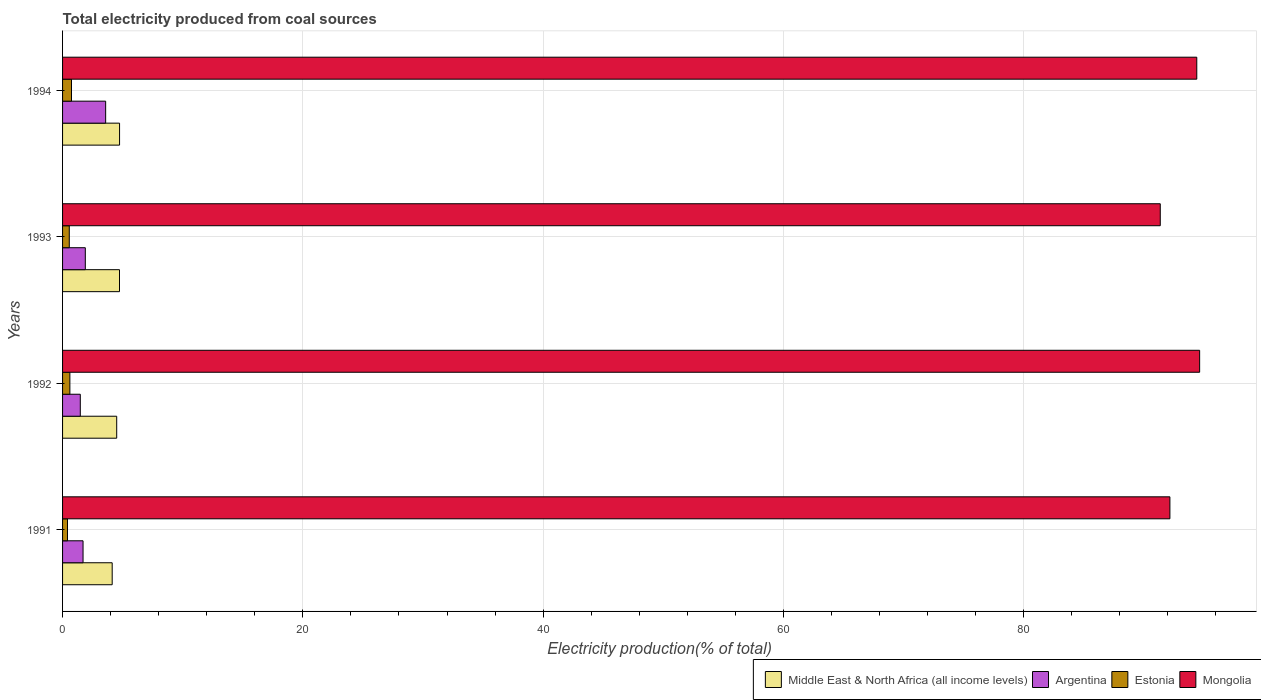Are the number of bars per tick equal to the number of legend labels?
Offer a terse response. Yes. How many bars are there on the 4th tick from the top?
Offer a very short reply. 4. How many bars are there on the 4th tick from the bottom?
Keep it short and to the point. 4. What is the label of the 2nd group of bars from the top?
Ensure brevity in your answer.  1993. What is the total electricity produced in Argentina in 1991?
Offer a very short reply. 1.7. Across all years, what is the maximum total electricity produced in Argentina?
Ensure brevity in your answer.  3.59. Across all years, what is the minimum total electricity produced in Mongolia?
Give a very brief answer. 91.36. In which year was the total electricity produced in Middle East & North Africa (all income levels) maximum?
Offer a terse response. 1994. In which year was the total electricity produced in Argentina minimum?
Give a very brief answer. 1992. What is the total total electricity produced in Middle East & North Africa (all income levels) in the graph?
Give a very brief answer. 18.12. What is the difference between the total electricity produced in Argentina in 1991 and that in 1994?
Make the answer very short. -1.88. What is the difference between the total electricity produced in Middle East & North Africa (all income levels) in 1992 and the total electricity produced in Estonia in 1991?
Make the answer very short. 4.1. What is the average total electricity produced in Argentina per year?
Your answer should be compact. 2.17. In the year 1991, what is the difference between the total electricity produced in Middle East & North Africa (all income levels) and total electricity produced in Argentina?
Make the answer very short. 2.43. What is the ratio of the total electricity produced in Middle East & North Africa (all income levels) in 1993 to that in 1994?
Offer a very short reply. 1. Is the total electricity produced in Argentina in 1991 less than that in 1993?
Your answer should be very brief. Yes. What is the difference between the highest and the second highest total electricity produced in Mongolia?
Offer a terse response. 0.24. What is the difference between the highest and the lowest total electricity produced in Middle East & North Africa (all income levels)?
Provide a short and direct response. 0.61. In how many years, is the total electricity produced in Estonia greater than the average total electricity produced in Estonia taken over all years?
Keep it short and to the point. 2. Is the sum of the total electricity produced in Estonia in 1992 and 1993 greater than the maximum total electricity produced in Argentina across all years?
Keep it short and to the point. No. What does the 2nd bar from the top in 1993 represents?
Keep it short and to the point. Estonia. Is it the case that in every year, the sum of the total electricity produced in Middle East & North Africa (all income levels) and total electricity produced in Argentina is greater than the total electricity produced in Mongolia?
Give a very brief answer. No. How many years are there in the graph?
Keep it short and to the point. 4. Are the values on the major ticks of X-axis written in scientific E-notation?
Keep it short and to the point. No. Does the graph contain any zero values?
Provide a short and direct response. No. How many legend labels are there?
Provide a short and direct response. 4. What is the title of the graph?
Give a very brief answer. Total electricity produced from coal sources. Does "St. Lucia" appear as one of the legend labels in the graph?
Provide a succinct answer. No. What is the label or title of the Y-axis?
Offer a very short reply. Years. What is the Electricity production(% of total) of Middle East & North Africa (all income levels) in 1991?
Keep it short and to the point. 4.13. What is the Electricity production(% of total) in Argentina in 1991?
Your answer should be compact. 1.7. What is the Electricity production(% of total) of Estonia in 1991?
Ensure brevity in your answer.  0.41. What is the Electricity production(% of total) in Mongolia in 1991?
Your answer should be very brief. 92.16. What is the Electricity production(% of total) in Middle East & North Africa (all income levels) in 1992?
Offer a very short reply. 4.51. What is the Electricity production(% of total) in Argentina in 1992?
Your response must be concise. 1.48. What is the Electricity production(% of total) of Estonia in 1992?
Give a very brief answer. 0.61. What is the Electricity production(% of total) of Mongolia in 1992?
Provide a succinct answer. 94.64. What is the Electricity production(% of total) of Middle East & North Africa (all income levels) in 1993?
Offer a terse response. 4.74. What is the Electricity production(% of total) of Argentina in 1993?
Give a very brief answer. 1.89. What is the Electricity production(% of total) in Estonia in 1993?
Offer a terse response. 0.56. What is the Electricity production(% of total) of Mongolia in 1993?
Your answer should be compact. 91.36. What is the Electricity production(% of total) of Middle East & North Africa (all income levels) in 1994?
Provide a succinct answer. 4.74. What is the Electricity production(% of total) in Argentina in 1994?
Give a very brief answer. 3.59. What is the Electricity production(% of total) in Estonia in 1994?
Offer a terse response. 0.74. What is the Electricity production(% of total) of Mongolia in 1994?
Provide a short and direct response. 94.4. Across all years, what is the maximum Electricity production(% of total) in Middle East & North Africa (all income levels)?
Your answer should be very brief. 4.74. Across all years, what is the maximum Electricity production(% of total) in Argentina?
Provide a short and direct response. 3.59. Across all years, what is the maximum Electricity production(% of total) of Estonia?
Ensure brevity in your answer.  0.74. Across all years, what is the maximum Electricity production(% of total) of Mongolia?
Provide a short and direct response. 94.64. Across all years, what is the minimum Electricity production(% of total) of Middle East & North Africa (all income levels)?
Offer a very short reply. 4.13. Across all years, what is the minimum Electricity production(% of total) in Argentina?
Provide a succinct answer. 1.48. Across all years, what is the minimum Electricity production(% of total) in Estonia?
Your response must be concise. 0.41. Across all years, what is the minimum Electricity production(% of total) of Mongolia?
Ensure brevity in your answer.  91.36. What is the total Electricity production(% of total) of Middle East & North Africa (all income levels) in the graph?
Your answer should be compact. 18.12. What is the total Electricity production(% of total) in Argentina in the graph?
Give a very brief answer. 8.66. What is the total Electricity production(% of total) of Estonia in the graph?
Provide a short and direct response. 2.32. What is the total Electricity production(% of total) of Mongolia in the graph?
Offer a very short reply. 372.57. What is the difference between the Electricity production(% of total) in Middle East & North Africa (all income levels) in 1991 and that in 1992?
Ensure brevity in your answer.  -0.38. What is the difference between the Electricity production(% of total) of Argentina in 1991 and that in 1992?
Your answer should be compact. 0.23. What is the difference between the Electricity production(% of total) of Estonia in 1991 and that in 1992?
Your answer should be compact. -0.2. What is the difference between the Electricity production(% of total) of Mongolia in 1991 and that in 1992?
Your response must be concise. -2.48. What is the difference between the Electricity production(% of total) of Middle East & North Africa (all income levels) in 1991 and that in 1993?
Make the answer very short. -0.61. What is the difference between the Electricity production(% of total) of Argentina in 1991 and that in 1993?
Make the answer very short. -0.19. What is the difference between the Electricity production(% of total) in Estonia in 1991 and that in 1993?
Your answer should be compact. -0.15. What is the difference between the Electricity production(% of total) of Mongolia in 1991 and that in 1993?
Offer a very short reply. 0.8. What is the difference between the Electricity production(% of total) of Middle East & North Africa (all income levels) in 1991 and that in 1994?
Offer a terse response. -0.61. What is the difference between the Electricity production(% of total) of Argentina in 1991 and that in 1994?
Make the answer very short. -1.88. What is the difference between the Electricity production(% of total) of Estonia in 1991 and that in 1994?
Provide a succinct answer. -0.33. What is the difference between the Electricity production(% of total) in Mongolia in 1991 and that in 1994?
Offer a very short reply. -2.24. What is the difference between the Electricity production(% of total) in Middle East & North Africa (all income levels) in 1992 and that in 1993?
Offer a very short reply. -0.23. What is the difference between the Electricity production(% of total) in Argentina in 1992 and that in 1993?
Your response must be concise. -0.42. What is the difference between the Electricity production(% of total) in Estonia in 1992 and that in 1993?
Your answer should be very brief. 0.05. What is the difference between the Electricity production(% of total) in Mongolia in 1992 and that in 1993?
Your answer should be very brief. 3.28. What is the difference between the Electricity production(% of total) of Middle East & North Africa (all income levels) in 1992 and that in 1994?
Provide a succinct answer. -0.24. What is the difference between the Electricity production(% of total) in Argentina in 1992 and that in 1994?
Ensure brevity in your answer.  -2.11. What is the difference between the Electricity production(% of total) of Estonia in 1992 and that in 1994?
Offer a terse response. -0.13. What is the difference between the Electricity production(% of total) in Mongolia in 1992 and that in 1994?
Give a very brief answer. 0.24. What is the difference between the Electricity production(% of total) of Middle East & North Africa (all income levels) in 1993 and that in 1994?
Offer a terse response. -0.01. What is the difference between the Electricity production(% of total) of Argentina in 1993 and that in 1994?
Offer a very short reply. -1.69. What is the difference between the Electricity production(% of total) of Estonia in 1993 and that in 1994?
Provide a short and direct response. -0.18. What is the difference between the Electricity production(% of total) in Mongolia in 1993 and that in 1994?
Provide a short and direct response. -3.04. What is the difference between the Electricity production(% of total) in Middle East & North Africa (all income levels) in 1991 and the Electricity production(% of total) in Argentina in 1992?
Your answer should be compact. 2.65. What is the difference between the Electricity production(% of total) of Middle East & North Africa (all income levels) in 1991 and the Electricity production(% of total) of Estonia in 1992?
Make the answer very short. 3.52. What is the difference between the Electricity production(% of total) of Middle East & North Africa (all income levels) in 1991 and the Electricity production(% of total) of Mongolia in 1992?
Your response must be concise. -90.51. What is the difference between the Electricity production(% of total) in Argentina in 1991 and the Electricity production(% of total) in Estonia in 1992?
Your response must be concise. 1.1. What is the difference between the Electricity production(% of total) in Argentina in 1991 and the Electricity production(% of total) in Mongolia in 1992?
Make the answer very short. -92.94. What is the difference between the Electricity production(% of total) of Estonia in 1991 and the Electricity production(% of total) of Mongolia in 1992?
Ensure brevity in your answer.  -94.23. What is the difference between the Electricity production(% of total) of Middle East & North Africa (all income levels) in 1991 and the Electricity production(% of total) of Argentina in 1993?
Give a very brief answer. 2.24. What is the difference between the Electricity production(% of total) of Middle East & North Africa (all income levels) in 1991 and the Electricity production(% of total) of Estonia in 1993?
Provide a short and direct response. 3.57. What is the difference between the Electricity production(% of total) in Middle East & North Africa (all income levels) in 1991 and the Electricity production(% of total) in Mongolia in 1993?
Your answer should be compact. -87.23. What is the difference between the Electricity production(% of total) in Argentina in 1991 and the Electricity production(% of total) in Estonia in 1993?
Your response must be concise. 1.15. What is the difference between the Electricity production(% of total) of Argentina in 1991 and the Electricity production(% of total) of Mongolia in 1993?
Give a very brief answer. -89.66. What is the difference between the Electricity production(% of total) of Estonia in 1991 and the Electricity production(% of total) of Mongolia in 1993?
Make the answer very short. -90.95. What is the difference between the Electricity production(% of total) in Middle East & North Africa (all income levels) in 1991 and the Electricity production(% of total) in Argentina in 1994?
Offer a very short reply. 0.54. What is the difference between the Electricity production(% of total) in Middle East & North Africa (all income levels) in 1991 and the Electricity production(% of total) in Estonia in 1994?
Keep it short and to the point. 3.39. What is the difference between the Electricity production(% of total) in Middle East & North Africa (all income levels) in 1991 and the Electricity production(% of total) in Mongolia in 1994?
Offer a very short reply. -90.27. What is the difference between the Electricity production(% of total) of Argentina in 1991 and the Electricity production(% of total) of Estonia in 1994?
Keep it short and to the point. 0.96. What is the difference between the Electricity production(% of total) in Argentina in 1991 and the Electricity production(% of total) in Mongolia in 1994?
Make the answer very short. -92.7. What is the difference between the Electricity production(% of total) of Estonia in 1991 and the Electricity production(% of total) of Mongolia in 1994?
Ensure brevity in your answer.  -93.99. What is the difference between the Electricity production(% of total) in Middle East & North Africa (all income levels) in 1992 and the Electricity production(% of total) in Argentina in 1993?
Offer a very short reply. 2.61. What is the difference between the Electricity production(% of total) in Middle East & North Africa (all income levels) in 1992 and the Electricity production(% of total) in Estonia in 1993?
Ensure brevity in your answer.  3.95. What is the difference between the Electricity production(% of total) in Middle East & North Africa (all income levels) in 1992 and the Electricity production(% of total) in Mongolia in 1993?
Provide a succinct answer. -86.86. What is the difference between the Electricity production(% of total) in Argentina in 1992 and the Electricity production(% of total) in Estonia in 1993?
Offer a terse response. 0.92. What is the difference between the Electricity production(% of total) of Argentina in 1992 and the Electricity production(% of total) of Mongolia in 1993?
Offer a terse response. -89.89. What is the difference between the Electricity production(% of total) in Estonia in 1992 and the Electricity production(% of total) in Mongolia in 1993?
Keep it short and to the point. -90.75. What is the difference between the Electricity production(% of total) in Middle East & North Africa (all income levels) in 1992 and the Electricity production(% of total) in Estonia in 1994?
Your answer should be very brief. 3.76. What is the difference between the Electricity production(% of total) of Middle East & North Africa (all income levels) in 1992 and the Electricity production(% of total) of Mongolia in 1994?
Ensure brevity in your answer.  -89.9. What is the difference between the Electricity production(% of total) of Argentina in 1992 and the Electricity production(% of total) of Estonia in 1994?
Your response must be concise. 0.73. What is the difference between the Electricity production(% of total) in Argentina in 1992 and the Electricity production(% of total) in Mongolia in 1994?
Make the answer very short. -92.93. What is the difference between the Electricity production(% of total) of Estonia in 1992 and the Electricity production(% of total) of Mongolia in 1994?
Ensure brevity in your answer.  -93.79. What is the difference between the Electricity production(% of total) of Middle East & North Africa (all income levels) in 1993 and the Electricity production(% of total) of Argentina in 1994?
Give a very brief answer. 1.15. What is the difference between the Electricity production(% of total) of Middle East & North Africa (all income levels) in 1993 and the Electricity production(% of total) of Estonia in 1994?
Offer a very short reply. 4. What is the difference between the Electricity production(% of total) in Middle East & North Africa (all income levels) in 1993 and the Electricity production(% of total) in Mongolia in 1994?
Make the answer very short. -89.66. What is the difference between the Electricity production(% of total) of Argentina in 1993 and the Electricity production(% of total) of Estonia in 1994?
Make the answer very short. 1.15. What is the difference between the Electricity production(% of total) of Argentina in 1993 and the Electricity production(% of total) of Mongolia in 1994?
Your response must be concise. -92.51. What is the difference between the Electricity production(% of total) of Estonia in 1993 and the Electricity production(% of total) of Mongolia in 1994?
Ensure brevity in your answer.  -93.84. What is the average Electricity production(% of total) of Middle East & North Africa (all income levels) per year?
Offer a terse response. 4.53. What is the average Electricity production(% of total) of Argentina per year?
Ensure brevity in your answer.  2.17. What is the average Electricity production(% of total) in Estonia per year?
Offer a very short reply. 0.58. What is the average Electricity production(% of total) of Mongolia per year?
Make the answer very short. 93.14. In the year 1991, what is the difference between the Electricity production(% of total) of Middle East & North Africa (all income levels) and Electricity production(% of total) of Argentina?
Your answer should be compact. 2.43. In the year 1991, what is the difference between the Electricity production(% of total) in Middle East & North Africa (all income levels) and Electricity production(% of total) in Estonia?
Keep it short and to the point. 3.72. In the year 1991, what is the difference between the Electricity production(% of total) of Middle East & North Africa (all income levels) and Electricity production(% of total) of Mongolia?
Offer a very short reply. -88.03. In the year 1991, what is the difference between the Electricity production(% of total) of Argentina and Electricity production(% of total) of Estonia?
Provide a short and direct response. 1.29. In the year 1991, what is the difference between the Electricity production(% of total) of Argentina and Electricity production(% of total) of Mongolia?
Make the answer very short. -90.46. In the year 1991, what is the difference between the Electricity production(% of total) of Estonia and Electricity production(% of total) of Mongolia?
Provide a succinct answer. -91.75. In the year 1992, what is the difference between the Electricity production(% of total) in Middle East & North Africa (all income levels) and Electricity production(% of total) in Argentina?
Ensure brevity in your answer.  3.03. In the year 1992, what is the difference between the Electricity production(% of total) in Middle East & North Africa (all income levels) and Electricity production(% of total) in Estonia?
Provide a succinct answer. 3.9. In the year 1992, what is the difference between the Electricity production(% of total) in Middle East & North Africa (all income levels) and Electricity production(% of total) in Mongolia?
Provide a succinct answer. -90.13. In the year 1992, what is the difference between the Electricity production(% of total) in Argentina and Electricity production(% of total) in Estonia?
Provide a short and direct response. 0.87. In the year 1992, what is the difference between the Electricity production(% of total) of Argentina and Electricity production(% of total) of Mongolia?
Provide a succinct answer. -93.16. In the year 1992, what is the difference between the Electricity production(% of total) in Estonia and Electricity production(% of total) in Mongolia?
Make the answer very short. -94.03. In the year 1993, what is the difference between the Electricity production(% of total) in Middle East & North Africa (all income levels) and Electricity production(% of total) in Argentina?
Offer a very short reply. 2.84. In the year 1993, what is the difference between the Electricity production(% of total) of Middle East & North Africa (all income levels) and Electricity production(% of total) of Estonia?
Make the answer very short. 4.18. In the year 1993, what is the difference between the Electricity production(% of total) of Middle East & North Africa (all income levels) and Electricity production(% of total) of Mongolia?
Ensure brevity in your answer.  -86.63. In the year 1993, what is the difference between the Electricity production(% of total) of Argentina and Electricity production(% of total) of Estonia?
Offer a very short reply. 1.33. In the year 1993, what is the difference between the Electricity production(% of total) of Argentina and Electricity production(% of total) of Mongolia?
Keep it short and to the point. -89.47. In the year 1993, what is the difference between the Electricity production(% of total) in Estonia and Electricity production(% of total) in Mongolia?
Your response must be concise. -90.8. In the year 1994, what is the difference between the Electricity production(% of total) in Middle East & North Africa (all income levels) and Electricity production(% of total) in Argentina?
Ensure brevity in your answer.  1.16. In the year 1994, what is the difference between the Electricity production(% of total) of Middle East & North Africa (all income levels) and Electricity production(% of total) of Estonia?
Provide a short and direct response. 4. In the year 1994, what is the difference between the Electricity production(% of total) in Middle East & North Africa (all income levels) and Electricity production(% of total) in Mongolia?
Keep it short and to the point. -89.66. In the year 1994, what is the difference between the Electricity production(% of total) of Argentina and Electricity production(% of total) of Estonia?
Keep it short and to the point. 2.84. In the year 1994, what is the difference between the Electricity production(% of total) in Argentina and Electricity production(% of total) in Mongolia?
Your answer should be compact. -90.82. In the year 1994, what is the difference between the Electricity production(% of total) in Estonia and Electricity production(% of total) in Mongolia?
Your answer should be very brief. -93.66. What is the ratio of the Electricity production(% of total) in Middle East & North Africa (all income levels) in 1991 to that in 1992?
Offer a terse response. 0.92. What is the ratio of the Electricity production(% of total) in Argentina in 1991 to that in 1992?
Your answer should be very brief. 1.15. What is the ratio of the Electricity production(% of total) in Estonia in 1991 to that in 1992?
Your answer should be very brief. 0.67. What is the ratio of the Electricity production(% of total) in Mongolia in 1991 to that in 1992?
Your answer should be very brief. 0.97. What is the ratio of the Electricity production(% of total) of Middle East & North Africa (all income levels) in 1991 to that in 1993?
Give a very brief answer. 0.87. What is the ratio of the Electricity production(% of total) of Argentina in 1991 to that in 1993?
Your response must be concise. 0.9. What is the ratio of the Electricity production(% of total) of Estonia in 1991 to that in 1993?
Ensure brevity in your answer.  0.73. What is the ratio of the Electricity production(% of total) of Mongolia in 1991 to that in 1993?
Your answer should be compact. 1.01. What is the ratio of the Electricity production(% of total) of Middle East & North Africa (all income levels) in 1991 to that in 1994?
Ensure brevity in your answer.  0.87. What is the ratio of the Electricity production(% of total) of Argentina in 1991 to that in 1994?
Your response must be concise. 0.48. What is the ratio of the Electricity production(% of total) of Estonia in 1991 to that in 1994?
Your response must be concise. 0.55. What is the ratio of the Electricity production(% of total) in Mongolia in 1991 to that in 1994?
Keep it short and to the point. 0.98. What is the ratio of the Electricity production(% of total) in Middle East & North Africa (all income levels) in 1992 to that in 1993?
Offer a very short reply. 0.95. What is the ratio of the Electricity production(% of total) of Argentina in 1992 to that in 1993?
Your answer should be very brief. 0.78. What is the ratio of the Electricity production(% of total) in Estonia in 1992 to that in 1993?
Offer a terse response. 1.09. What is the ratio of the Electricity production(% of total) of Mongolia in 1992 to that in 1993?
Your answer should be very brief. 1.04. What is the ratio of the Electricity production(% of total) of Argentina in 1992 to that in 1994?
Your answer should be compact. 0.41. What is the ratio of the Electricity production(% of total) of Estonia in 1992 to that in 1994?
Keep it short and to the point. 0.82. What is the ratio of the Electricity production(% of total) of Mongolia in 1992 to that in 1994?
Offer a terse response. 1. What is the ratio of the Electricity production(% of total) in Argentina in 1993 to that in 1994?
Give a very brief answer. 0.53. What is the ratio of the Electricity production(% of total) of Estonia in 1993 to that in 1994?
Offer a terse response. 0.75. What is the ratio of the Electricity production(% of total) in Mongolia in 1993 to that in 1994?
Your response must be concise. 0.97. What is the difference between the highest and the second highest Electricity production(% of total) of Middle East & North Africa (all income levels)?
Your answer should be compact. 0.01. What is the difference between the highest and the second highest Electricity production(% of total) in Argentina?
Make the answer very short. 1.69. What is the difference between the highest and the second highest Electricity production(% of total) in Estonia?
Provide a succinct answer. 0.13. What is the difference between the highest and the second highest Electricity production(% of total) of Mongolia?
Make the answer very short. 0.24. What is the difference between the highest and the lowest Electricity production(% of total) of Middle East & North Africa (all income levels)?
Offer a very short reply. 0.61. What is the difference between the highest and the lowest Electricity production(% of total) in Argentina?
Ensure brevity in your answer.  2.11. What is the difference between the highest and the lowest Electricity production(% of total) in Estonia?
Offer a terse response. 0.33. What is the difference between the highest and the lowest Electricity production(% of total) of Mongolia?
Your response must be concise. 3.28. 